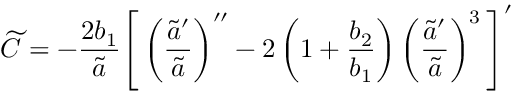<formula> <loc_0><loc_0><loc_500><loc_500>{ \widetilde { C } } = - \frac { 2 b _ { 1 } } { \tilde { a } } \left [ \left ( \frac { { \tilde { a } } ^ { \prime } } { { \tilde { a } } } \right ) ^ { \prime \prime } - 2 \left ( 1 + \frac { b _ { 2 } } { b _ { 1 } } \right ) \left ( \frac { { \tilde { a } } ^ { \prime } } { { \tilde { a } } } \right ) ^ { 3 } \right ] ^ { \prime }</formula> 